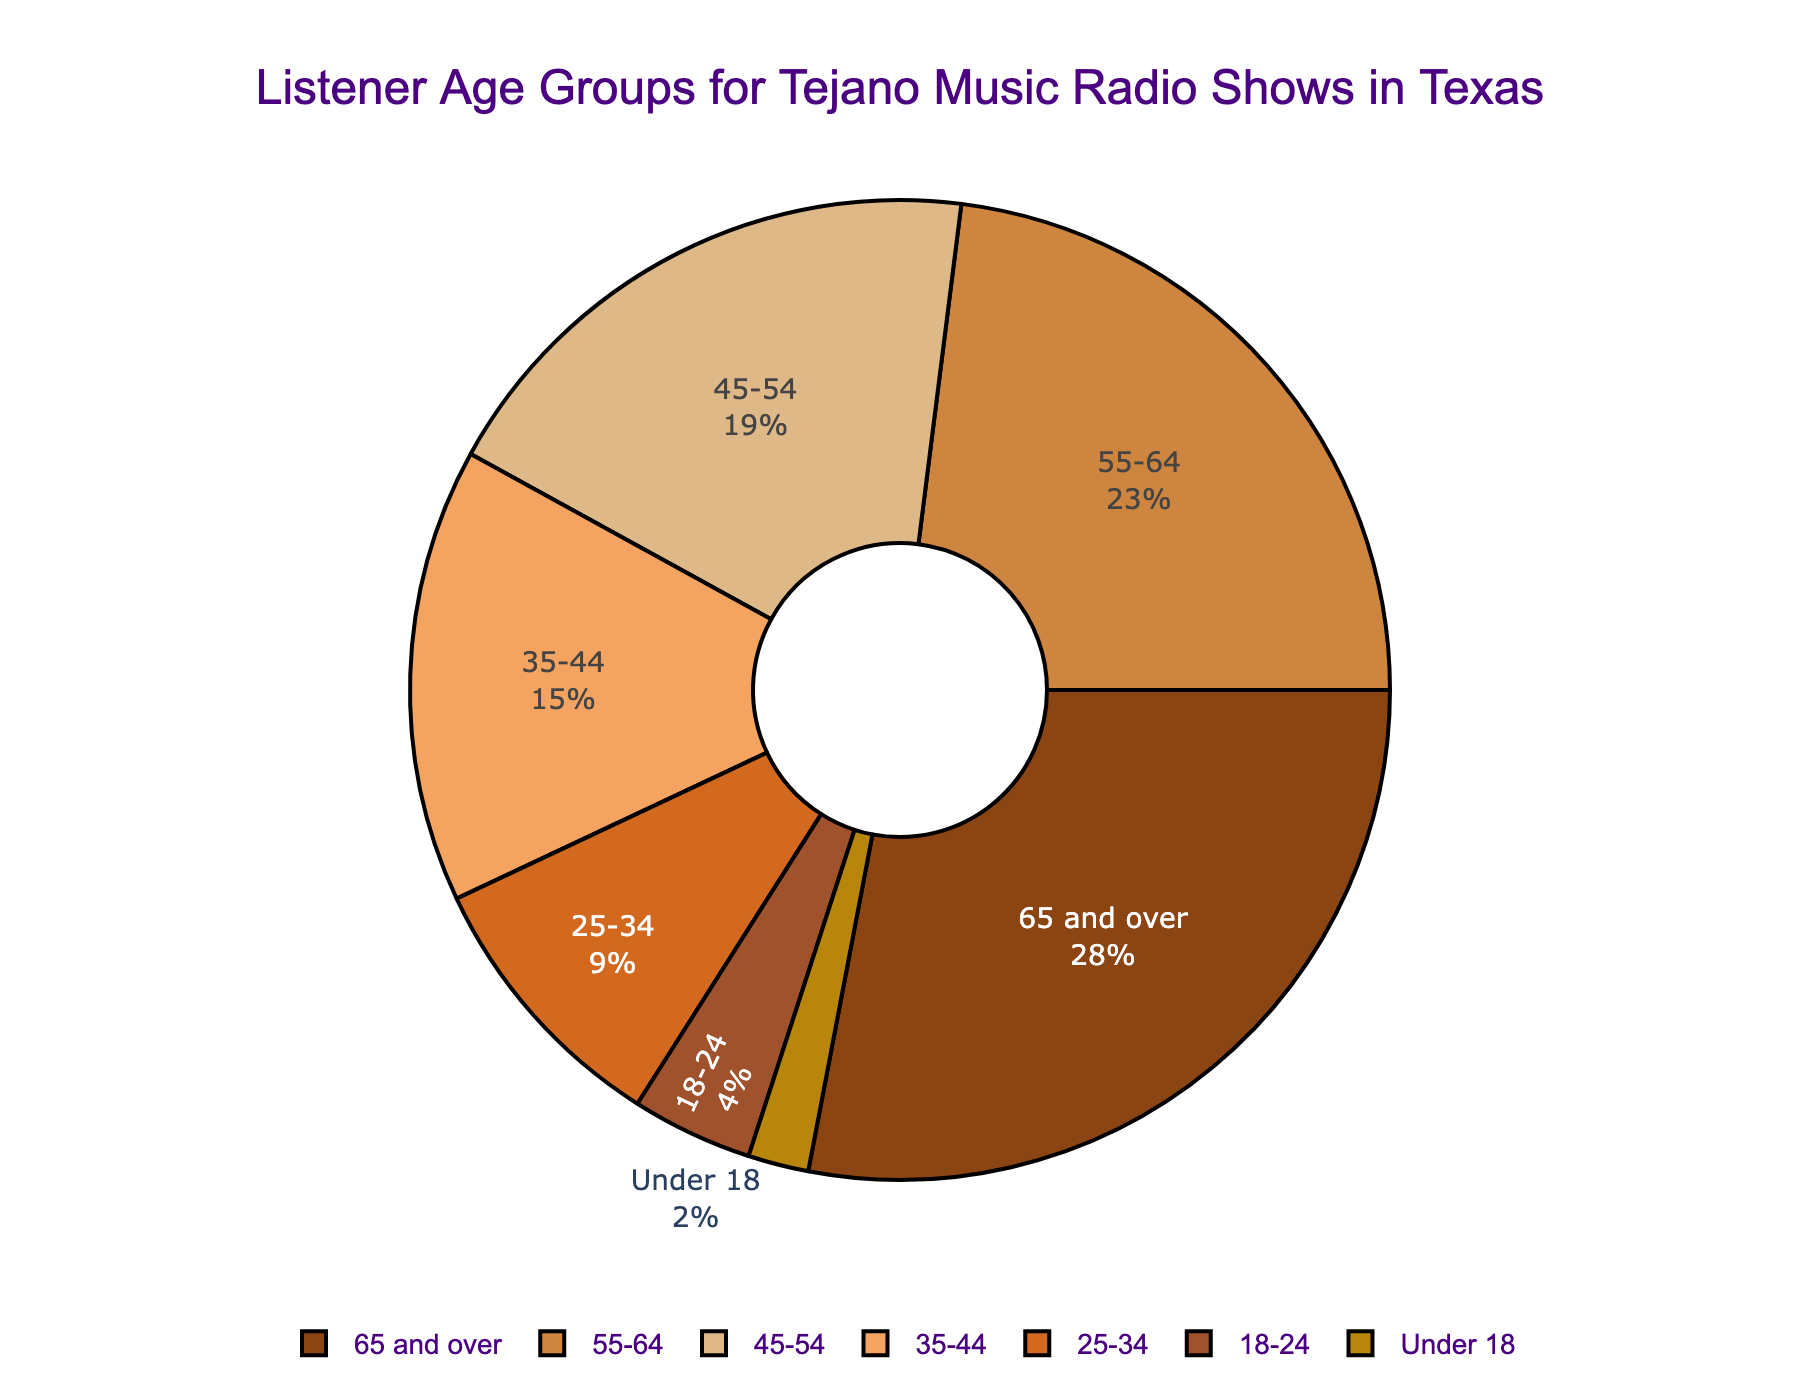What's the largest listener age group for Tejano music radio shows in Texas? The segment with the highest percentage represents the largest age group. In the figure, the "65 and over" group has the largest percentage at 28%
Answer: 65 and over What's the combined percentage of listeners aged 55 and older? To find the combined percentage of listeners aged 55 and older, add the percentages of the "65 and over" group (28%) and the "55-64" group (23%). So, 28% + 23% = 51%
Answer: 51% Which age group has the smallest percentage of listeners? The smallest segment in the pie chart represents the age group with the smallest percentage. The "Under 18" group has the smallest percentage at 2%
Answer: Under 18 How many age groups have percentages greater than 20%? To find the number of groups with percentages greater than 20%, count the segments with values above 20%. Both "65 and over" (28%) and "55-64" (23%) exceed 20%, resulting in two groups
Answer: 2 What's the difference in percentage between listeners aged 45-54 and those aged 18-24? Subtract the percentage of the 18-24 group (4%) from the 45-54 group (19%). Thus, 19% - 4% = 15%
Answer: 15% Which age group is represented by the color brown? Each color represents a different age group, and in the provided pie chart, the "65 and over" segment is shown in brown
Answer: 65 and over What is the total percentage of listeners under the age of 35? To find the total percentage of listeners under 35, add the percentages for "25-34" (9%), "18-24" (4%), and "Under 18" (2%). So, 9% + 4% + 2% = 15%
Answer: 15% Is the percentage of listeners aged 35-44 greater than the percentage of listeners under 18? Compare the two percentages: the 35-44 group (15%) and the under 18 group (2%). Since 15% is greater than 2%, the answer is yes
Answer: Yes What visual characteristic distinguishes the 55-64 age group segment? The 55-64 age group segment has a noticeable color (tan) and is the second-largest segment in the pie chart
Answer: Tan, second-largest How does the percentage of listeners aged 45-54 compare to that of listeners aged 55-64? Compare the percentages: The 45-54 group has 19%, while the 55-64 group has 23%. The 45-54 group has a smaller percentage.
Answer: 45-54 has a smaller percentage 